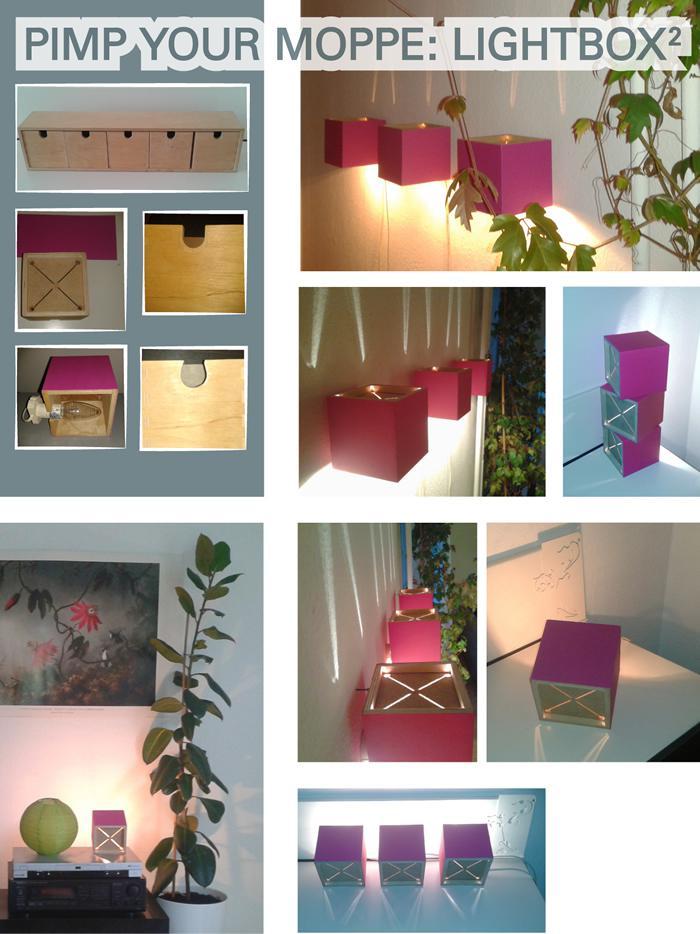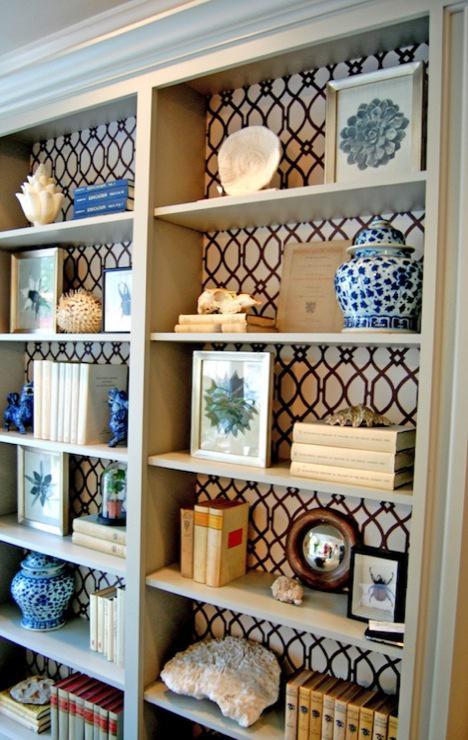The first image is the image on the left, the second image is the image on the right. Considering the images on both sides, is "In one image, a shelf unit that is two shelves wide and at least three shelves tall is open at the back to a wall with a decorative overall design." valid? Answer yes or no. Yes. The first image is the image on the left, the second image is the image on the right. Evaluate the accuracy of this statement regarding the images: "One of the bookcases as a patterned back wall.". Is it true? Answer yes or no. Yes. 